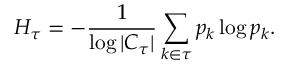Convert formula to latex. <formula><loc_0><loc_0><loc_500><loc_500>H _ { \tau } = - \frac { 1 } { \log | C _ { \tau } | } \sum _ { k \in \tau } p _ { k } \log p _ { k } .</formula> 